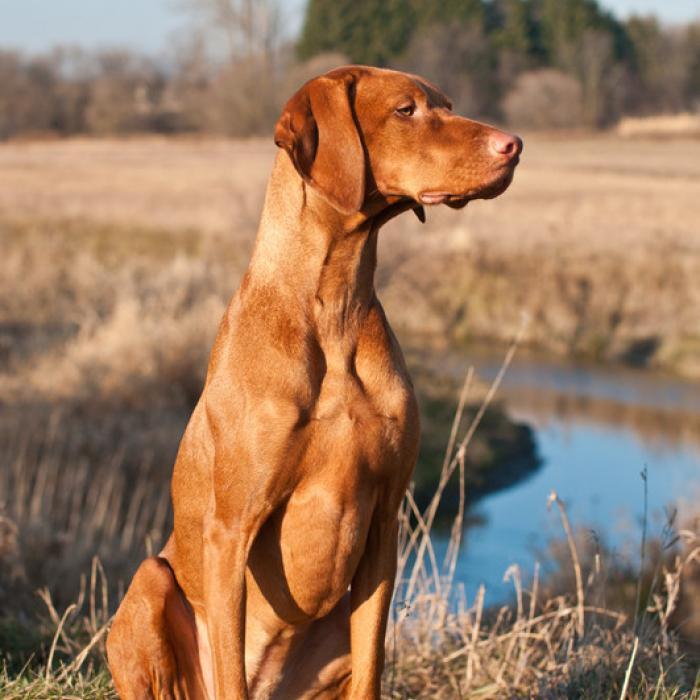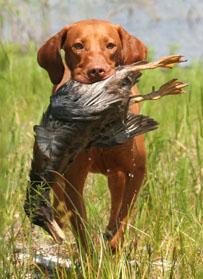The first image is the image on the left, the second image is the image on the right. For the images shown, is this caption "A dog has something in its mouth in the right image." true? Answer yes or no. Yes. The first image is the image on the left, the second image is the image on the right. Examine the images to the left and right. Is the description "The dog in the left image is standing on all fours on grass with its body in profile, and the dog on the right has its body turned leftward." accurate? Answer yes or no. No. 